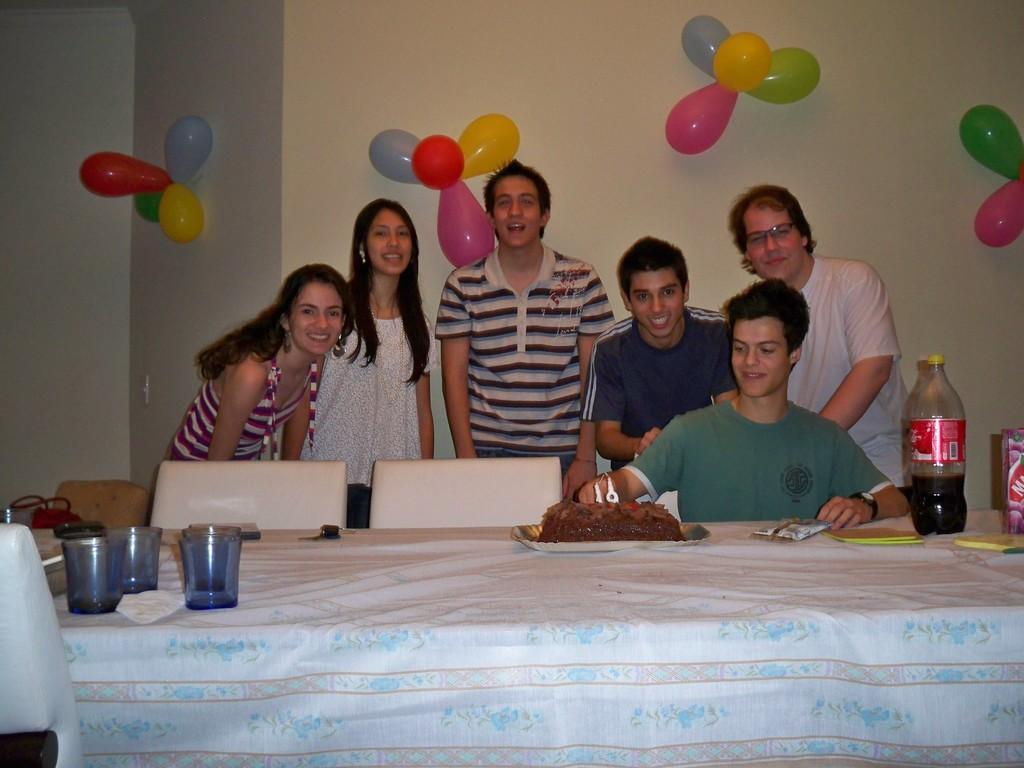In one or two sentences, can you explain what this image depicts? In this picture we can see a group of people where some are standing and one man is sitting and they are smiling and in front of them there is table and on table we can see glasses, tissue paper, bottle, tin, cake and in background we can see wall with balloons. 